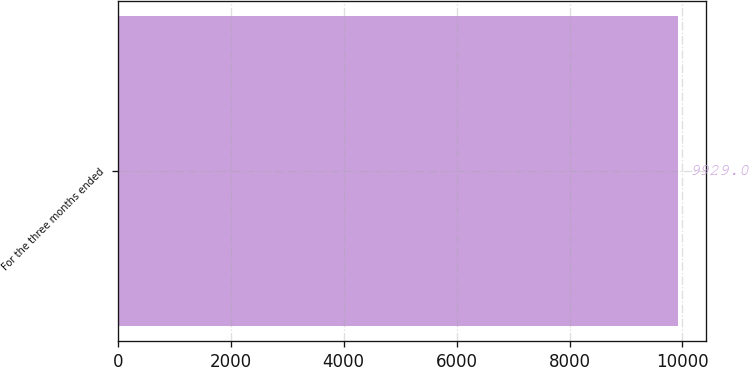Convert chart. <chart><loc_0><loc_0><loc_500><loc_500><bar_chart><fcel>For the three months ended<nl><fcel>9929<nl></chart> 